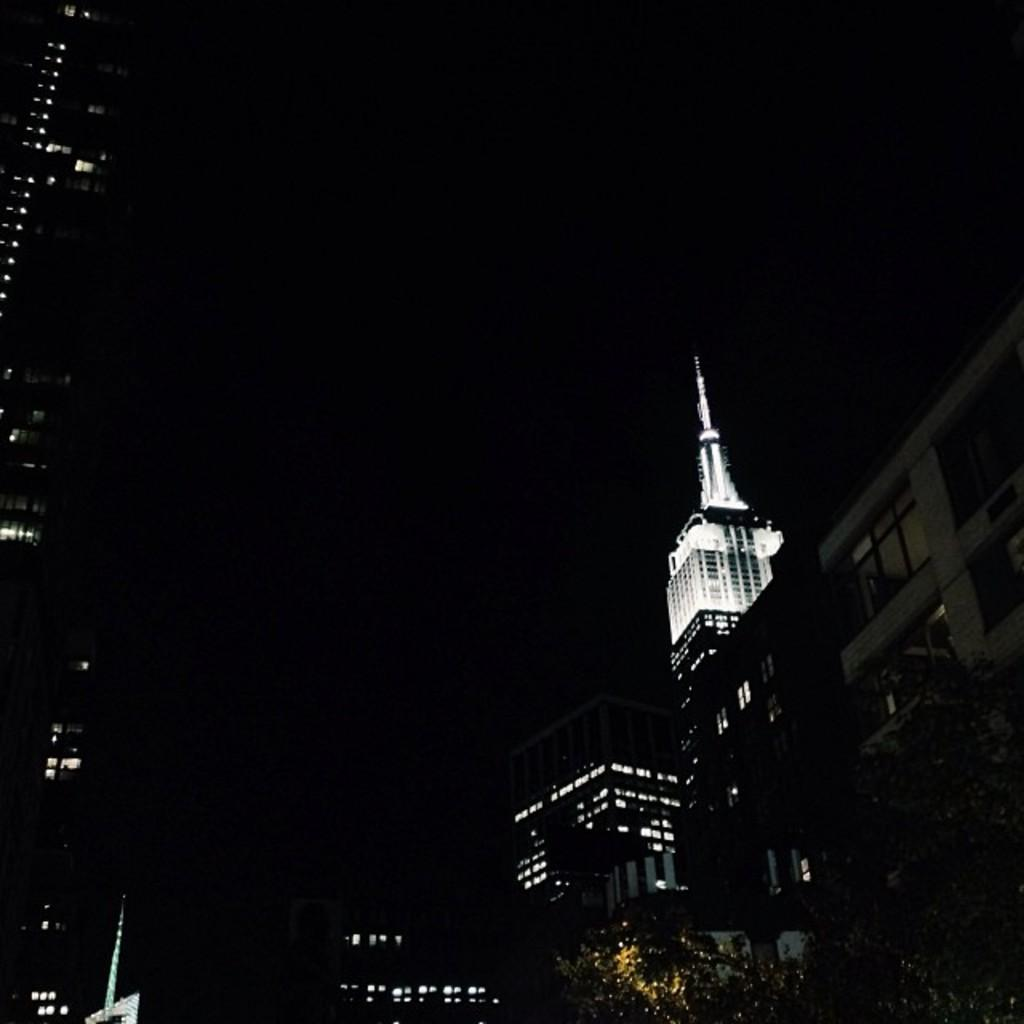What structures are present on both sides of the image? There are buildings on either side of the image. What feature do the buildings have? The buildings have lights. When was the image taken? The image was taken at night time. What type of hospital can be seen in the image? There is no hospital present in the image; it features buildings with lights at night time. How many people are in the group visible in the image? There is no group of people present in the image; it only shows buildings with lights at night time. 